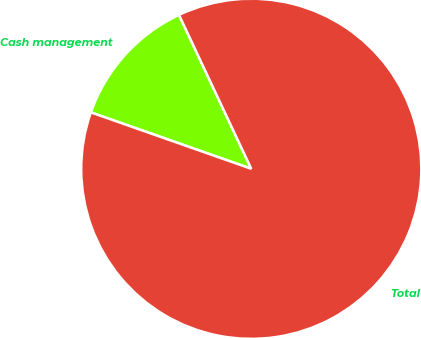Convert chart to OTSL. <chart><loc_0><loc_0><loc_500><loc_500><pie_chart><fcel>Cash management<fcel>Total<nl><fcel>12.63%<fcel>87.37%<nl></chart> 